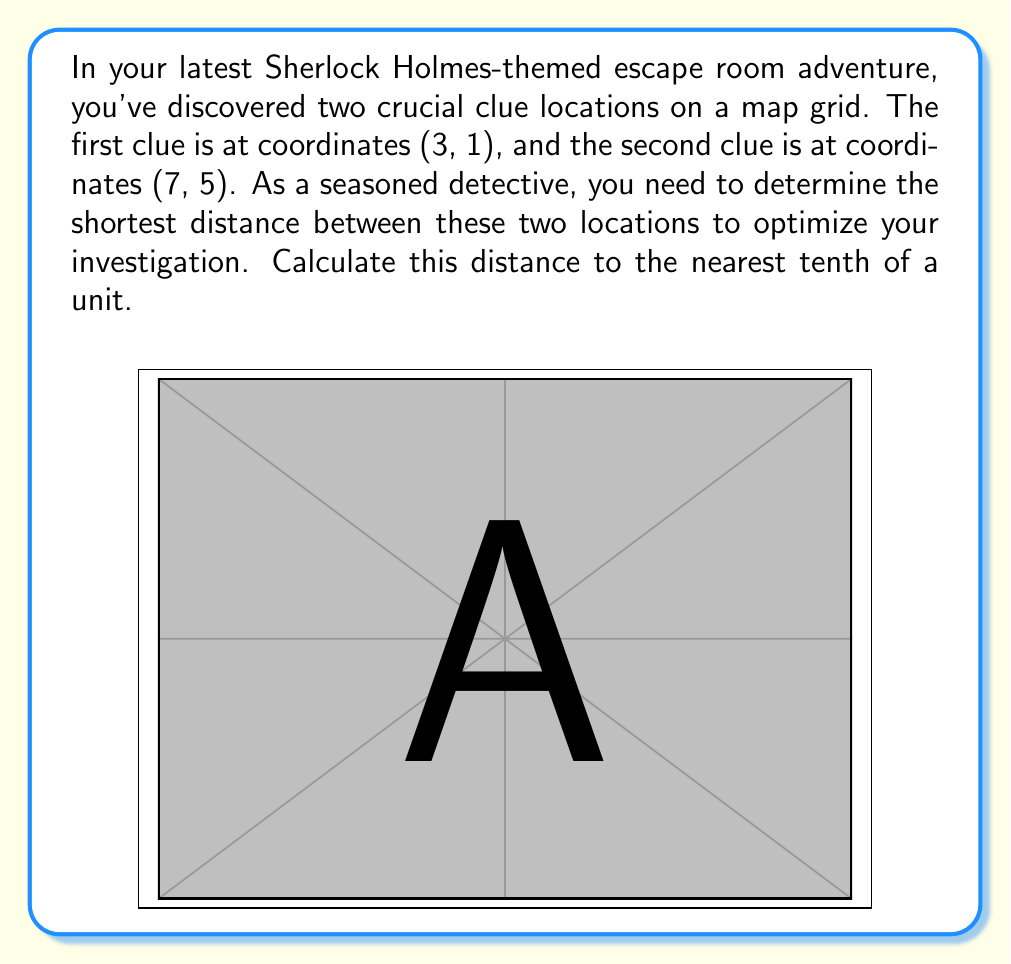Solve this math problem. To solve this problem, we'll use the distance formula derived from the Pythagorean theorem. The formula calculates the straight-line distance between two points on a coordinate plane.

1) The distance formula is:
   $$d = \sqrt{(x_2 - x_1)^2 + (y_2 - y_1)^2}$$
   where $(x_1, y_1)$ is the first point and $(x_2, y_2)$ is the second point.

2) We have:
   $(x_1, y_1) = (3, 1)$ and $(x_2, y_2) = (7, 5)$

3) Let's substitute these values into the formula:
   $$d = \sqrt{(7 - 3)^2 + (5 - 1)^2}$$

4) Simplify inside the parentheses:
   $$d = \sqrt{4^2 + 4^2}$$

5) Calculate the squares:
   $$d = \sqrt{16 + 16}$$

6) Add inside the square root:
   $$d = \sqrt{32}$$

7) Simplify the square root:
   $$d = 4\sqrt{2} \approx 5.66$$

8) Rounding to the nearest tenth:
   $$d \approx 5.7$$

Therefore, the shortest distance between the two clue locations is approximately 5.7 units.
Answer: 5.7 units 